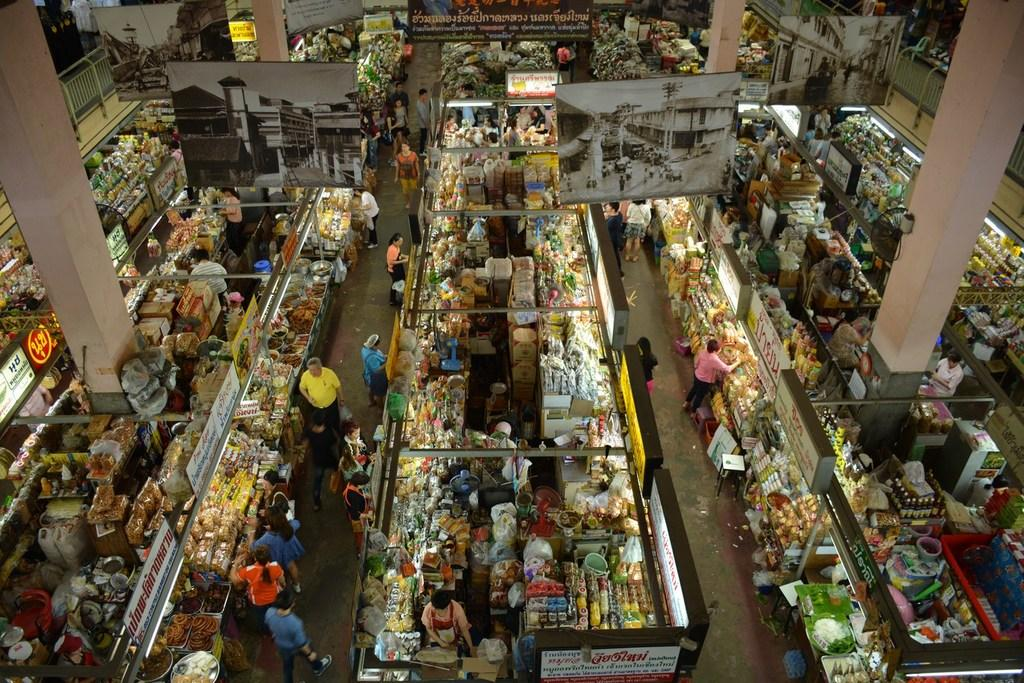<image>
Relay a brief, clear account of the picture shown. A lively market with lots of signs in asian language 